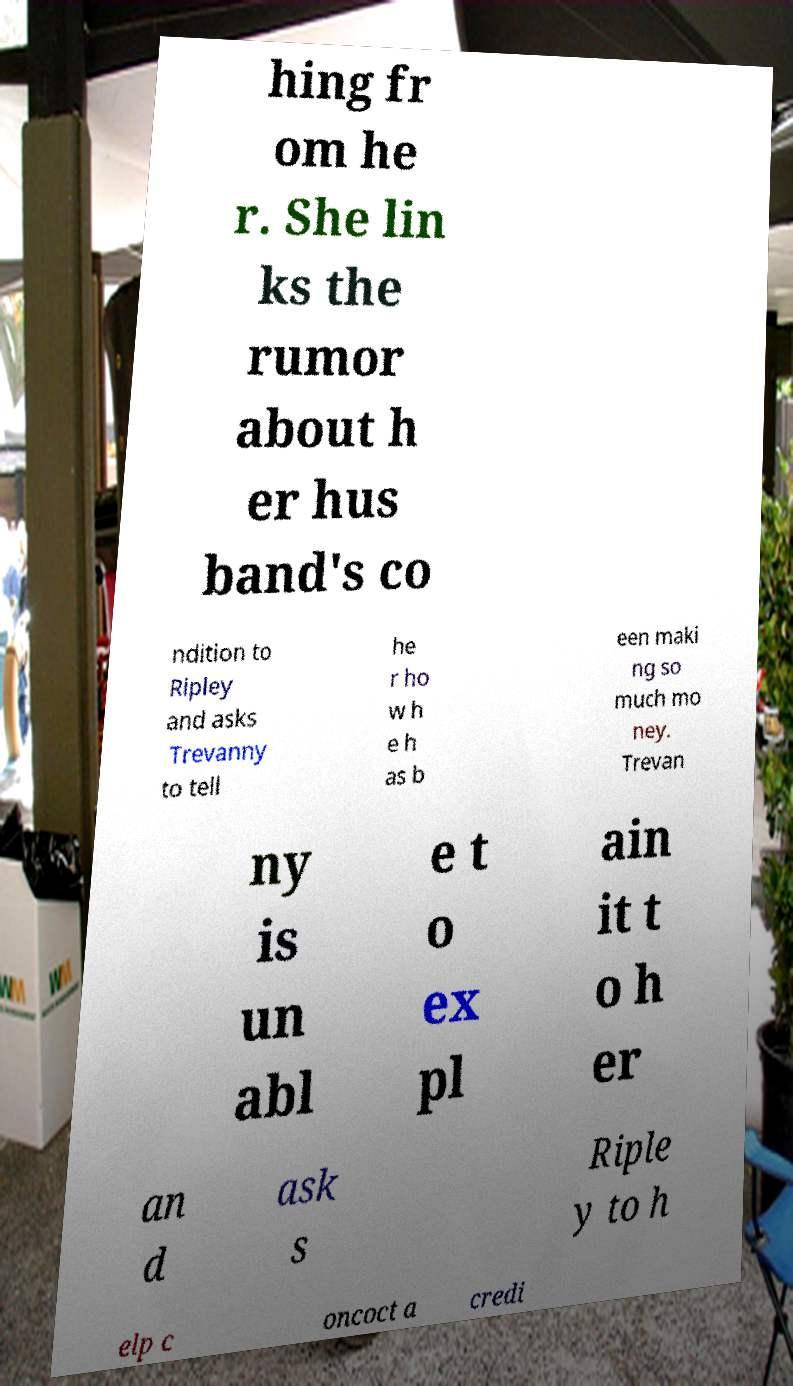Can you accurately transcribe the text from the provided image for me? hing fr om he r. She lin ks the rumor about h er hus band's co ndition to Ripley and asks Trevanny to tell he r ho w h e h as b een maki ng so much mo ney. Trevan ny is un abl e t o ex pl ain it t o h er an d ask s Riple y to h elp c oncoct a credi 